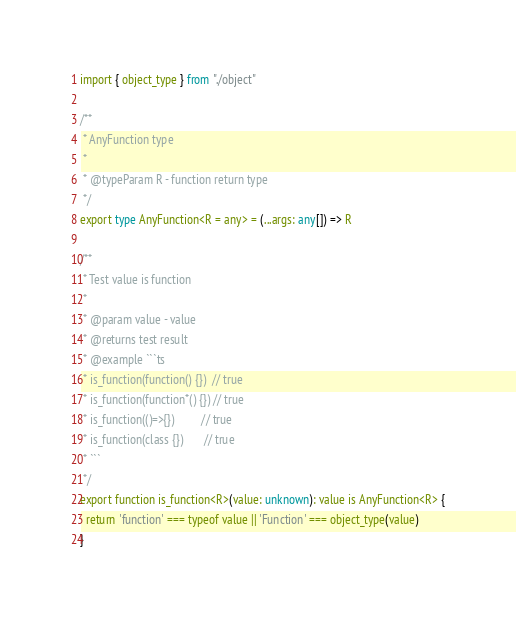Convert code to text. <code><loc_0><loc_0><loc_500><loc_500><_TypeScript_>import { object_type } from "./object"

/**
 * AnyFunction type
 * 
 * @typeParam R - function return type
 */
export type AnyFunction<R = any> = (...args: any[]) => R

/**
 * Test value is function
 * 
 * @param value - value
 * @returns test result
 * @example ```ts
 * is_function(function() {})  // true
 * is_function(function*() {}) // true
 * is_function(()=>{})         // true
 * is_function(class {})       // true
 * ```
 */
export function is_function<R>(value: unknown): value is AnyFunction<R> {
  return 'function' === typeof value || 'Function' === object_type(value)
}
</code> 